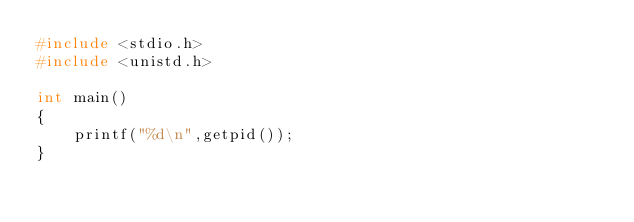Convert code to text. <code><loc_0><loc_0><loc_500><loc_500><_C_>#include <stdio.h>
#include <unistd.h>

int main()
{
	printf("%d\n",getpid());
}
</code> 